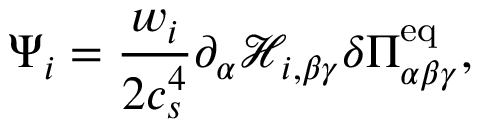Convert formula to latex. <formula><loc_0><loc_0><loc_500><loc_500>\Psi _ { i } = \frac { w _ { i } } { 2 c _ { s } ^ { 4 } } \partial _ { \alpha } \mathcal { H } _ { i , \beta \gamma } \delta \Pi _ { \alpha \beta \gamma } ^ { e q } ,</formula> 